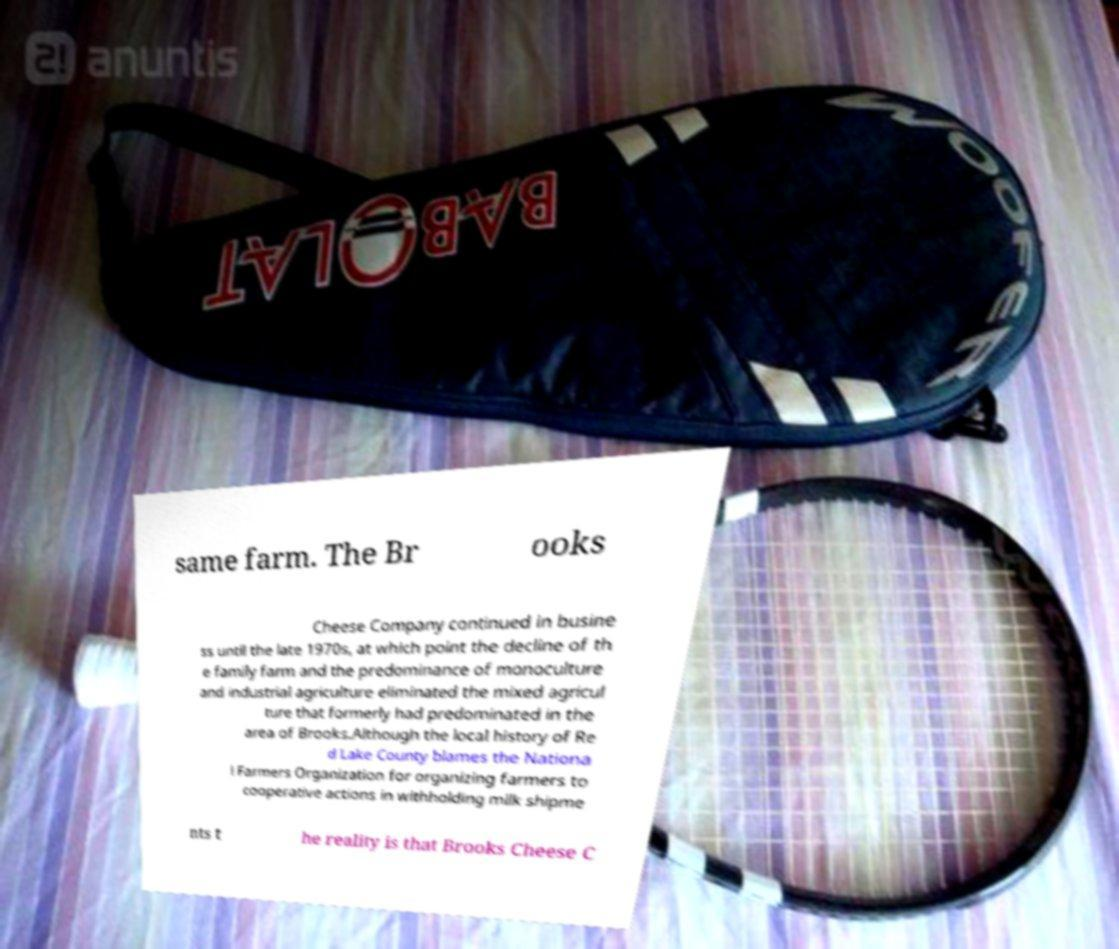Can you read and provide the text displayed in the image?This photo seems to have some interesting text. Can you extract and type it out for me? same farm. The Br ooks Cheese Company continued in busine ss until the late 1970s, at which point the decline of th e family farm and the predominance of monoculture and industrial agriculture eliminated the mixed agricul ture that formerly had predominated in the area of Brooks.Although the local history of Re d Lake County blames the Nationa l Farmers Organization for organizing farmers to cooperative actions in withholding milk shipme nts t he reality is that Brooks Cheese C 